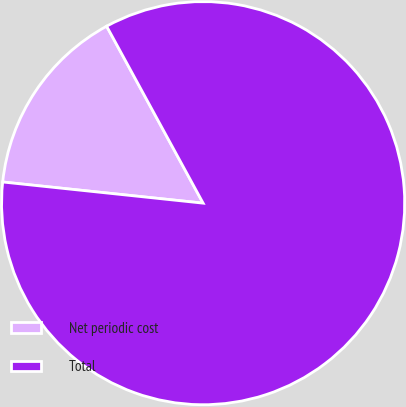Convert chart to OTSL. <chart><loc_0><loc_0><loc_500><loc_500><pie_chart><fcel>Net periodic cost<fcel>Total<nl><fcel>15.38%<fcel>84.62%<nl></chart> 